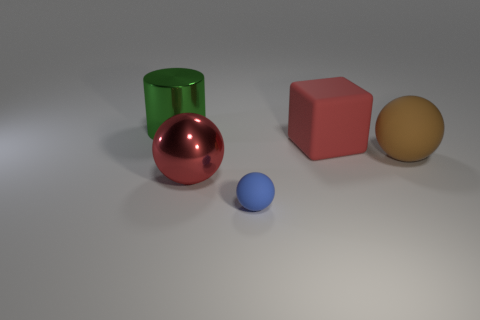There is a big object that is the same color as the shiny sphere; what shape is it?
Keep it short and to the point. Cube. Is the color of the large metal ball the same as the cylinder?
Your answer should be very brief. No. What number of green objects are either large cylinders or tiny matte objects?
Provide a short and direct response. 1. Do the matte sphere behind the tiny blue rubber sphere and the small thing have the same color?
Offer a very short reply. No. What is the shape of the big object that is the same material as the cylinder?
Provide a succinct answer. Sphere. What is the color of the big thing that is on the left side of the cube and to the right of the large green shiny object?
Your answer should be very brief. Red. There is a matte sphere on the left side of the sphere behind the large red ball; what size is it?
Keep it short and to the point. Small. Are there any rubber balls of the same color as the big cylinder?
Keep it short and to the point. No. Is the number of red balls that are right of the big red block the same as the number of tiny purple cylinders?
Keep it short and to the point. Yes. How many brown spheres are there?
Make the answer very short. 1. 